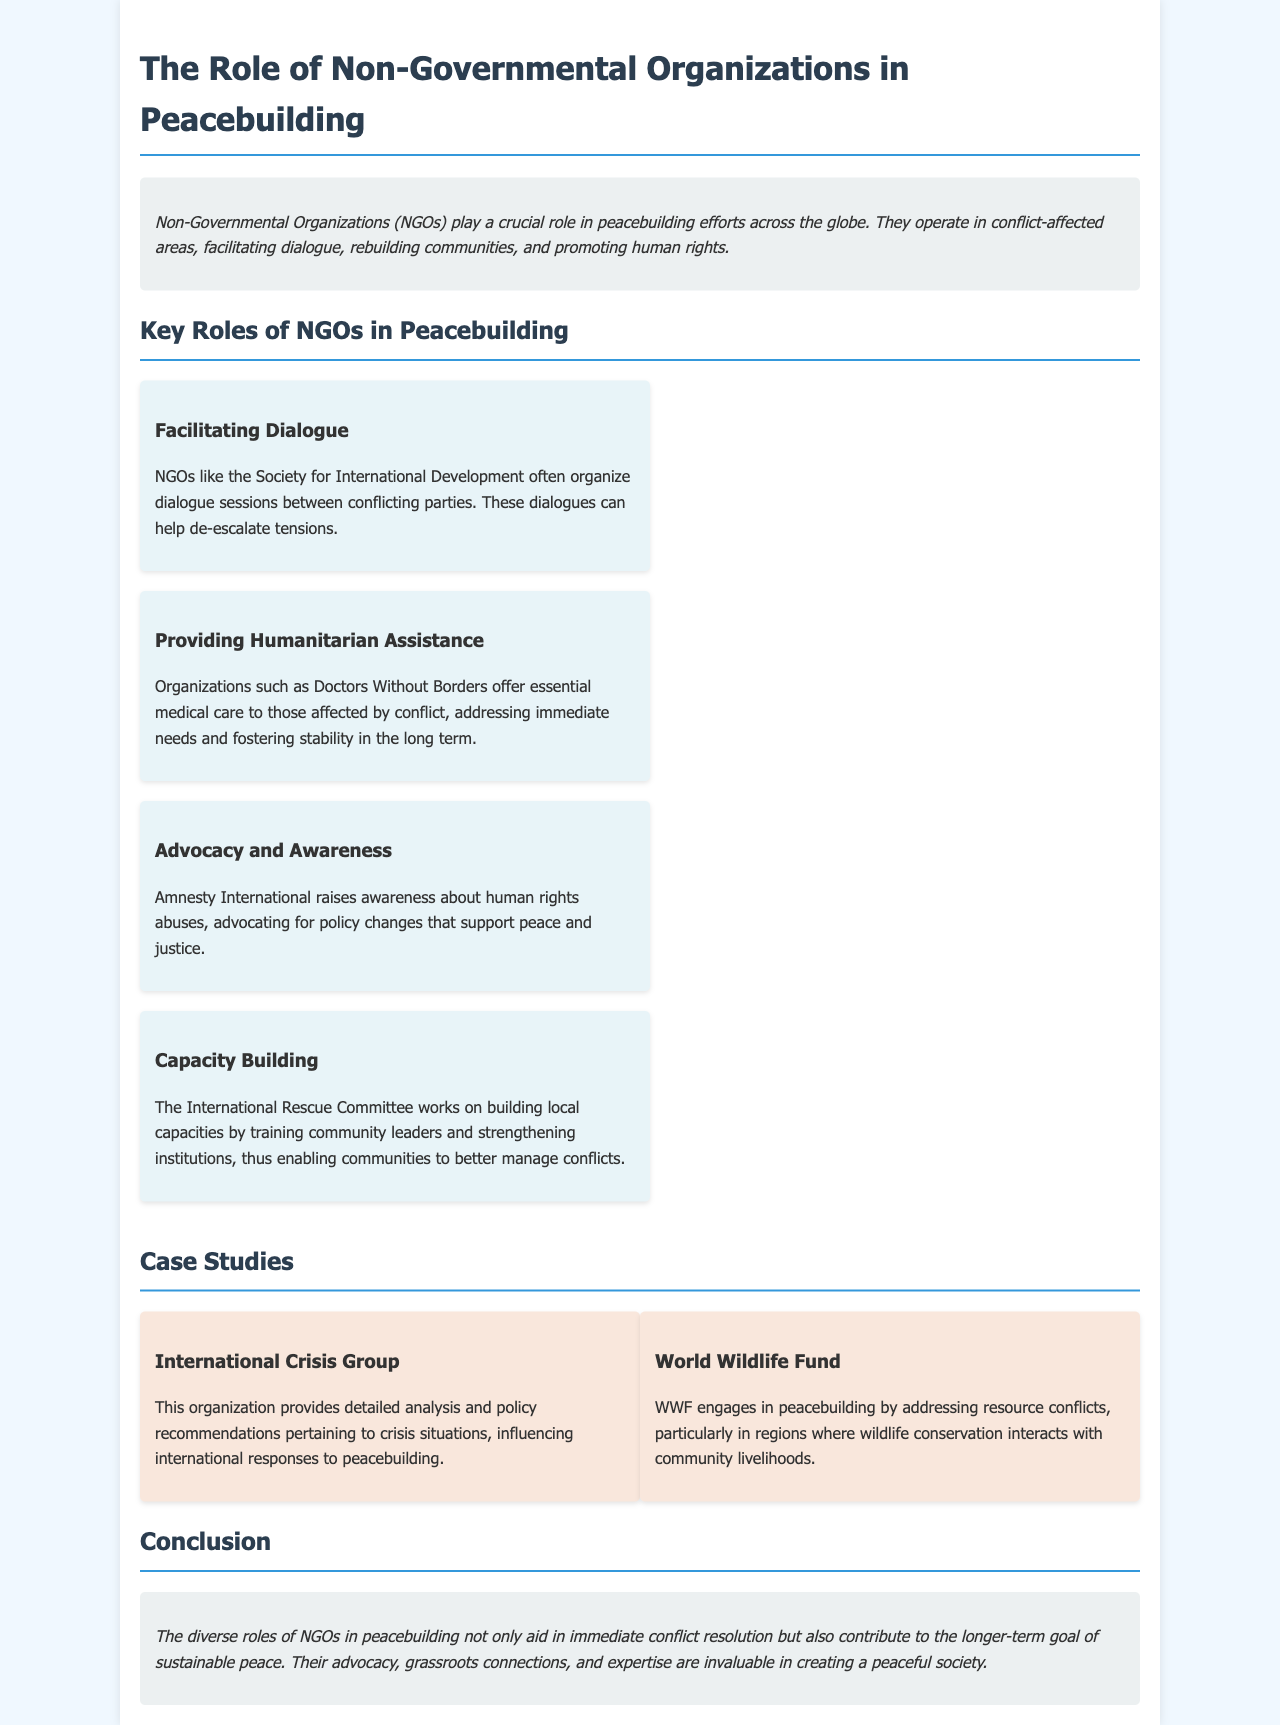What do NGOs facilitate in peacebuilding? NGOs facilitate dialogue between conflicting parties, which helps to de-escalate tensions.
Answer: Dialogue What organization provides medical care in conflict zones? Doctors Without Borders offers essential medical care to those affected by conflict.
Answer: Doctors Without Borders What is a role of Amnesty International? Amnesty International raises awareness about human rights abuses and advocates for policy changes supporting peace and justice.
Answer: Advocacy Which organization is known for capacity building? The International Rescue Committee works on building local capacities by training community leaders.
Answer: International Rescue Committee What type of analysis does the International Crisis Group provide? This organization provides detailed analysis and policy recommendations pertaining to crisis situations.
Answer: Analysis What issue does the World Wildlife Fund address in relation to peacebuilding? WWF engages in peacebuilding by addressing resource conflicts, especially regarding wildlife conservation and community livelihoods.
Answer: Resource conflicts What color is the background of the container in the document? The container has a background color of white, contrasting with the light blue page background.
Answer: White How many key roles of NGOs in peacebuilding are mentioned? The document lists four key roles of NGOs in peacebuilding efforts.
Answer: Four What is the main goal of NGOs' roles in peacebuilding? The roles of NGOs not only aid in immediate conflict resolution but also contribute to the longer-term goal of sustainable peace.
Answer: Sustainable peace 